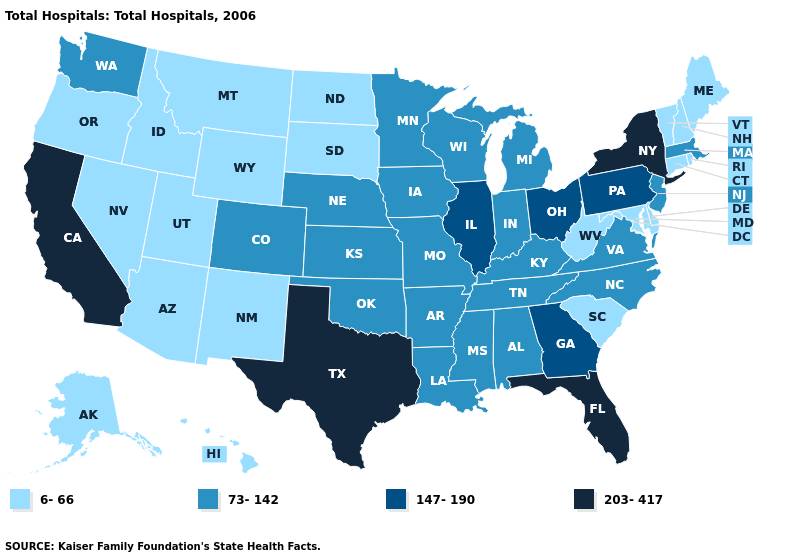Does Nebraska have the lowest value in the MidWest?
Answer briefly. No. Which states hav the highest value in the Northeast?
Be succinct. New York. Among the states that border Wisconsin , which have the lowest value?
Short answer required. Iowa, Michigan, Minnesota. Name the states that have a value in the range 73-142?
Write a very short answer. Alabama, Arkansas, Colorado, Indiana, Iowa, Kansas, Kentucky, Louisiana, Massachusetts, Michigan, Minnesota, Mississippi, Missouri, Nebraska, New Jersey, North Carolina, Oklahoma, Tennessee, Virginia, Washington, Wisconsin. What is the value of Maine?
Answer briefly. 6-66. Name the states that have a value in the range 73-142?
Be succinct. Alabama, Arkansas, Colorado, Indiana, Iowa, Kansas, Kentucky, Louisiana, Massachusetts, Michigan, Minnesota, Mississippi, Missouri, Nebraska, New Jersey, North Carolina, Oklahoma, Tennessee, Virginia, Washington, Wisconsin. What is the highest value in the USA?
Quick response, please. 203-417. What is the value of Kentucky?
Write a very short answer. 73-142. Which states have the highest value in the USA?
Short answer required. California, Florida, New York, Texas. What is the value of Iowa?
Write a very short answer. 73-142. Among the states that border Colorado , does Nebraska have the highest value?
Short answer required. Yes. Among the states that border West Virginia , which have the highest value?
Write a very short answer. Ohio, Pennsylvania. What is the highest value in the West ?
Short answer required. 203-417. What is the highest value in states that border Delaware?
Be succinct. 147-190. 